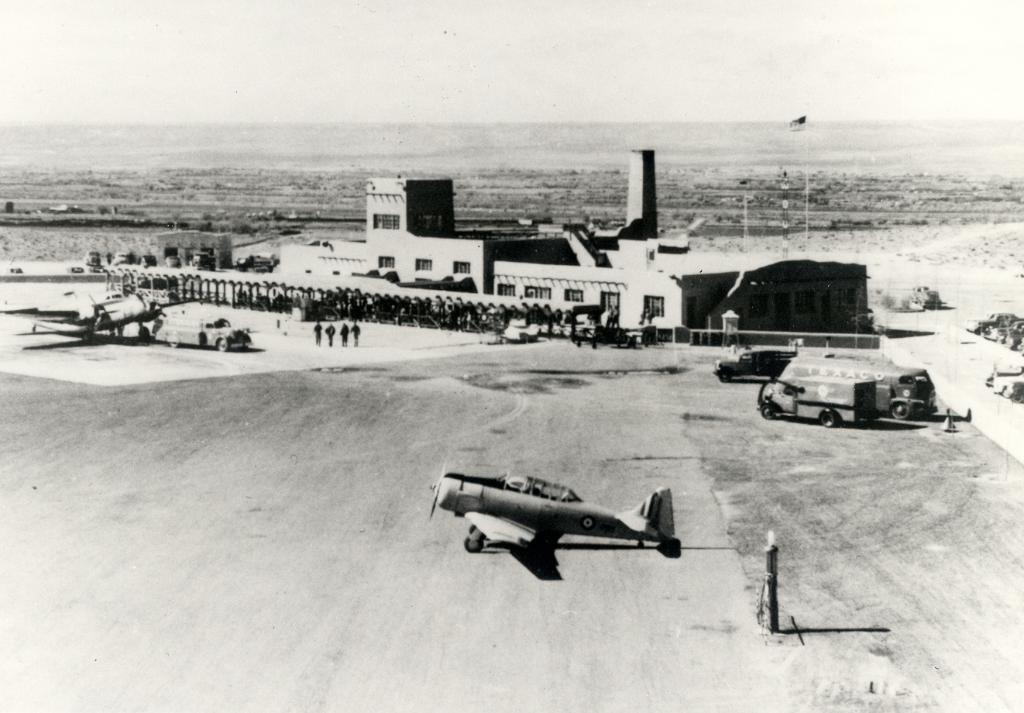What is the color scheme of the image? The image is black and white. What types of subjects can be seen in the image? There are vehicles, people, buildings, and objects in the image. Can you describe the presence of a flag in the image? Yes, there is a flag in the image. How does the friction between the seat and the person affect the movement of the vehicle in the image? There is no information about friction, seats, or movement of the vehicle in the image, as it is a black and white image with various subjects. 